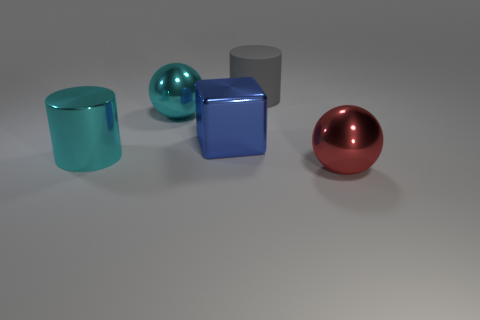What is the large blue cube made of?
Your answer should be compact. Metal. There is a big metallic object that is both in front of the cyan sphere and left of the large blue shiny object; what is its color?
Keep it short and to the point. Cyan. Is the number of large red metallic spheres that are on the right side of the cyan metal sphere the same as the number of gray matte objects that are in front of the large blue metallic block?
Keep it short and to the point. No. There is a cylinder that is the same material as the large cyan ball; what color is it?
Your answer should be very brief. Cyan. There is a large block; is it the same color as the metal ball to the right of the gray thing?
Your answer should be very brief. No. There is a object in front of the cylinder on the left side of the large gray thing; is there a cyan shiny cylinder right of it?
Offer a terse response. No. The large cyan thing that is made of the same material as the cyan ball is what shape?
Provide a short and direct response. Cylinder. Is there anything else that has the same shape as the gray object?
Offer a terse response. Yes. What shape is the large red thing?
Provide a succinct answer. Sphere. Is the shape of the cyan shiny thing behind the big blue metallic thing the same as  the big blue object?
Offer a very short reply. No. 